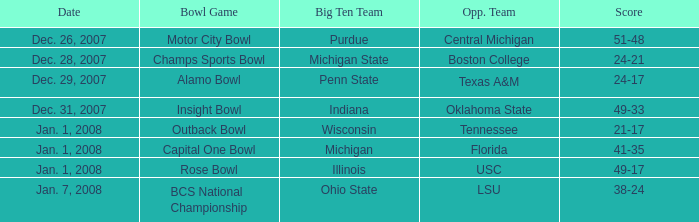Who was the opposing team in the game with a score of 21-17? Tennessee. 